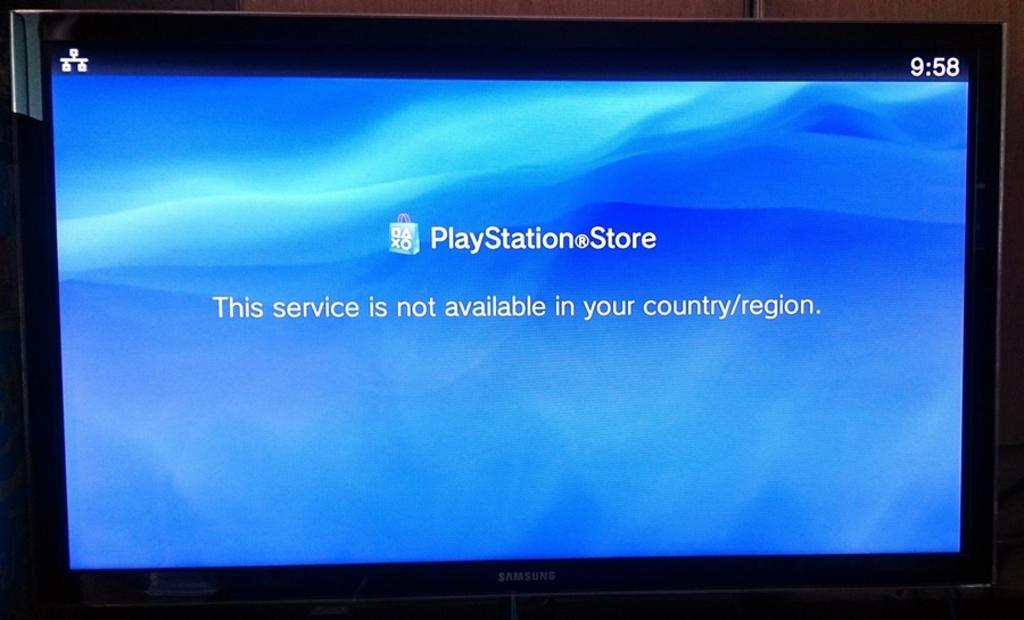<image>
Offer a succinct explanation of the picture presented. a PlayStation store icon on a blue screen 